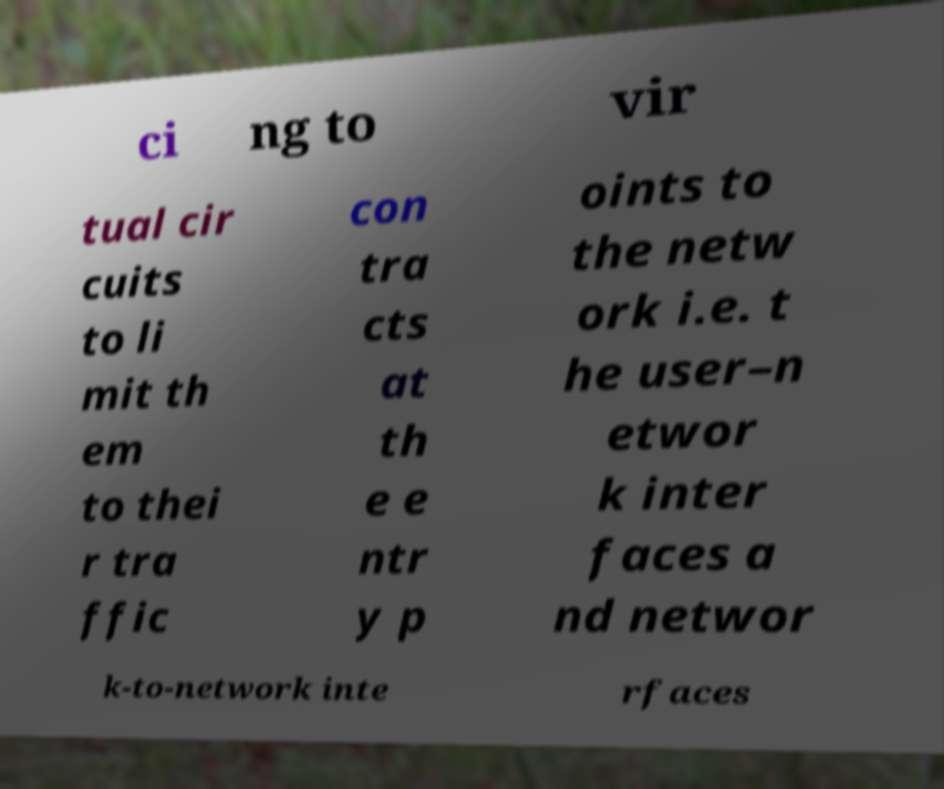Could you assist in decoding the text presented in this image and type it out clearly? ci ng to vir tual cir cuits to li mit th em to thei r tra ffic con tra cts at th e e ntr y p oints to the netw ork i.e. t he user–n etwor k inter faces a nd networ k-to-network inte rfaces 